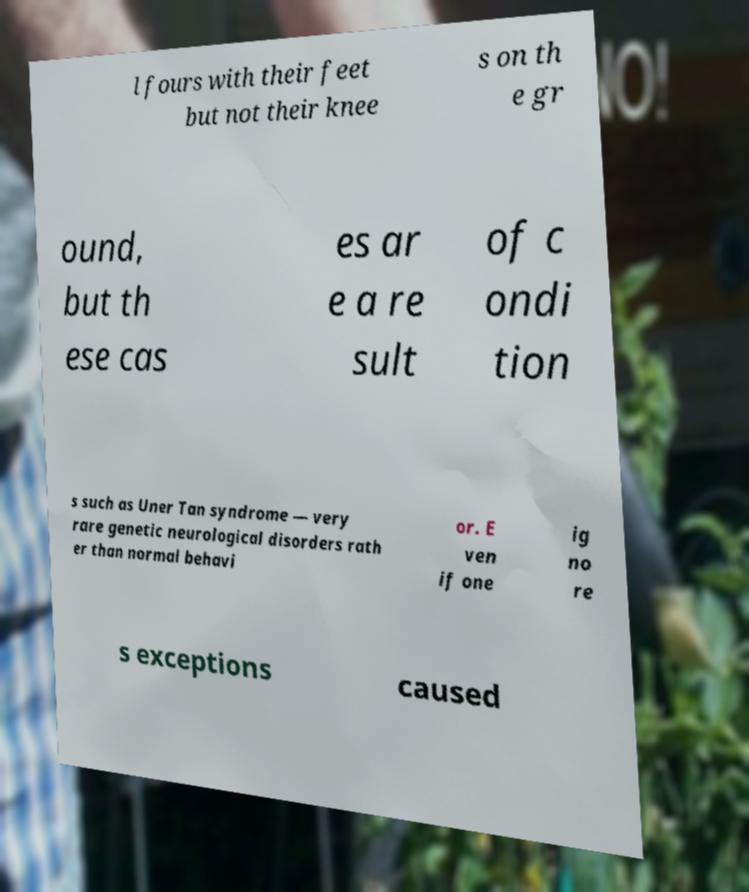Can you accurately transcribe the text from the provided image for me? l fours with their feet but not their knee s on th e gr ound, but th ese cas es ar e a re sult of c ondi tion s such as Uner Tan syndrome — very rare genetic neurological disorders rath er than normal behavi or. E ven if one ig no re s exceptions caused 